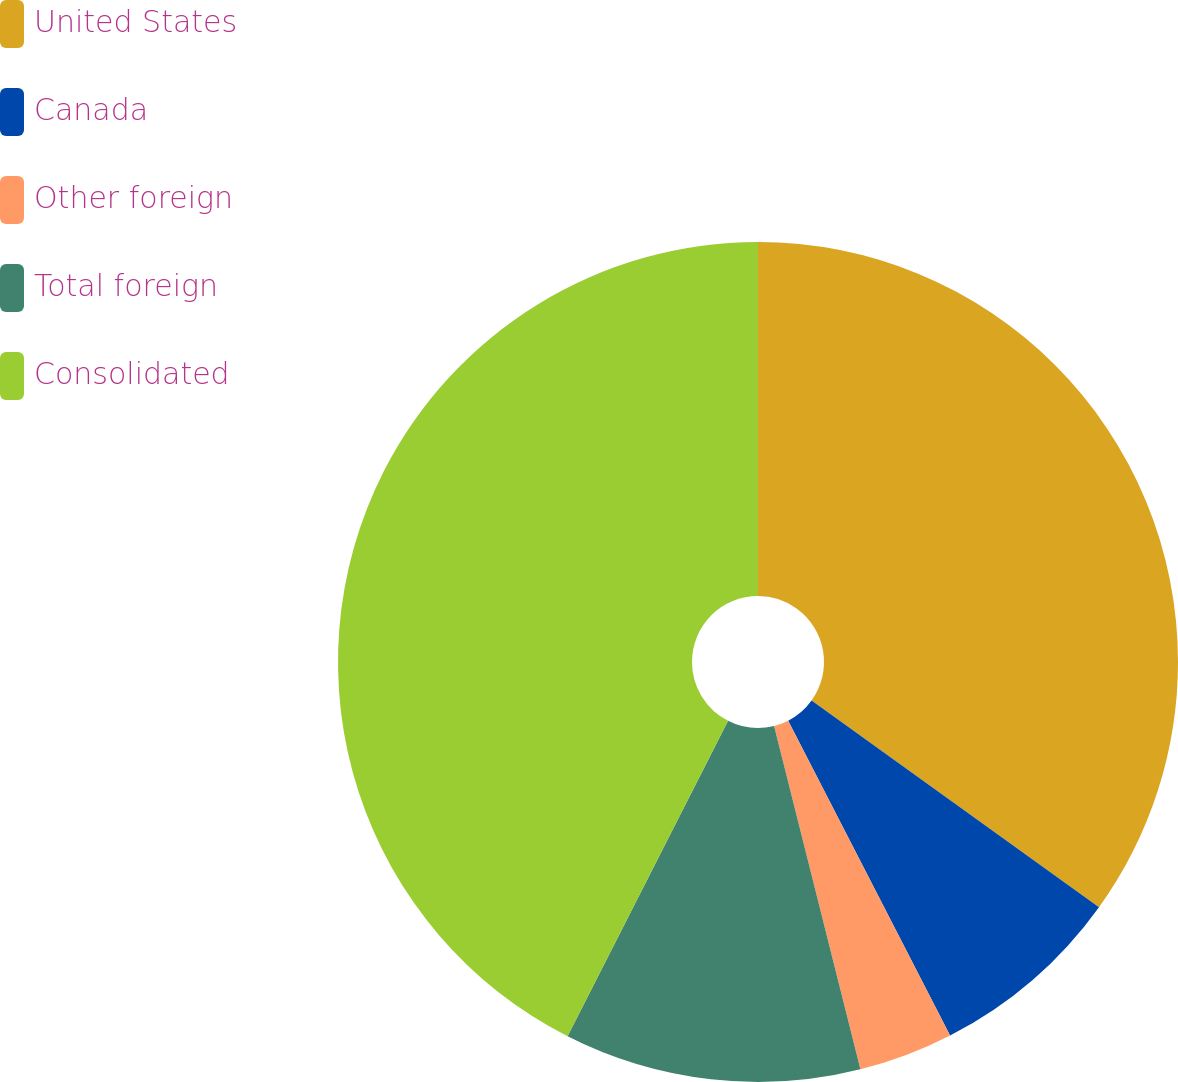Convert chart to OTSL. <chart><loc_0><loc_0><loc_500><loc_500><pie_chart><fcel>United States<fcel>Canada<fcel>Other foreign<fcel>Total foreign<fcel>Consolidated<nl><fcel>34.92%<fcel>7.52%<fcel>3.64%<fcel>11.41%<fcel>42.51%<nl></chart> 